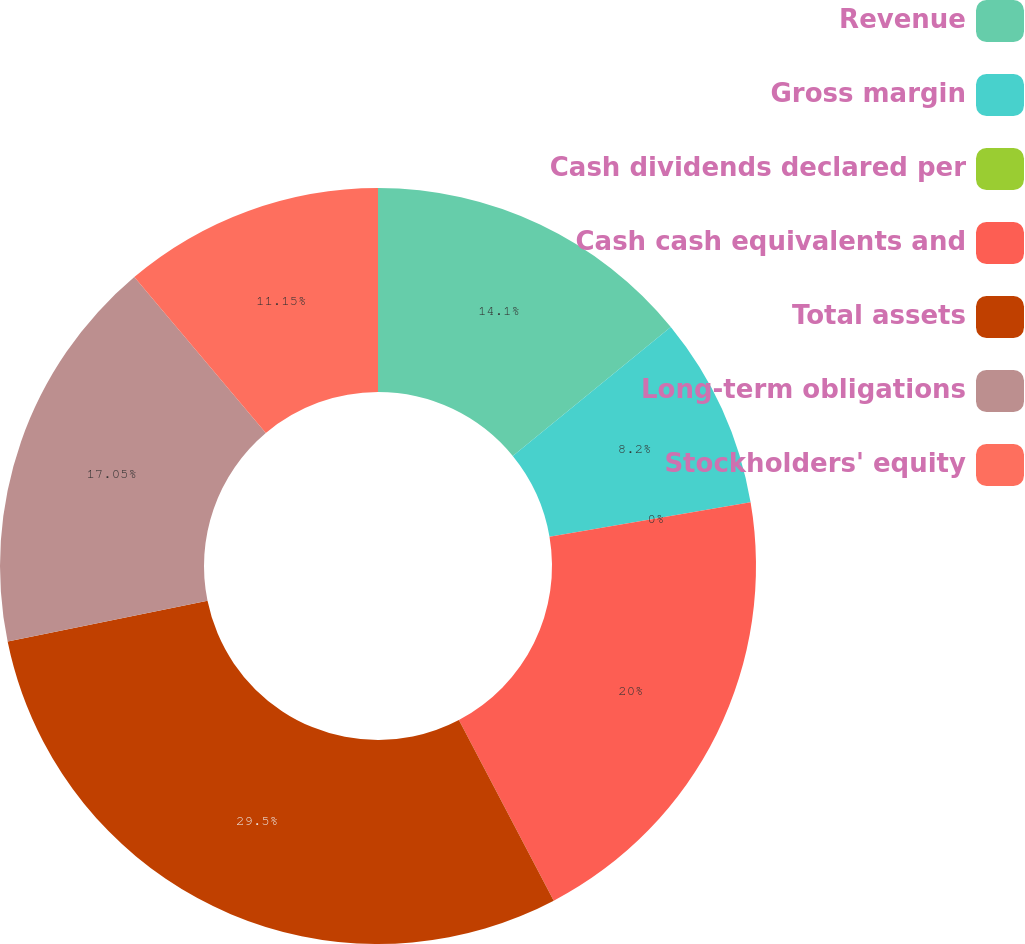Convert chart to OTSL. <chart><loc_0><loc_0><loc_500><loc_500><pie_chart><fcel>Revenue<fcel>Gross margin<fcel>Cash dividends declared per<fcel>Cash cash equivalents and<fcel>Total assets<fcel>Long-term obligations<fcel>Stockholders' equity<nl><fcel>14.1%<fcel>8.2%<fcel>0.0%<fcel>20.0%<fcel>29.49%<fcel>17.05%<fcel>11.15%<nl></chart> 